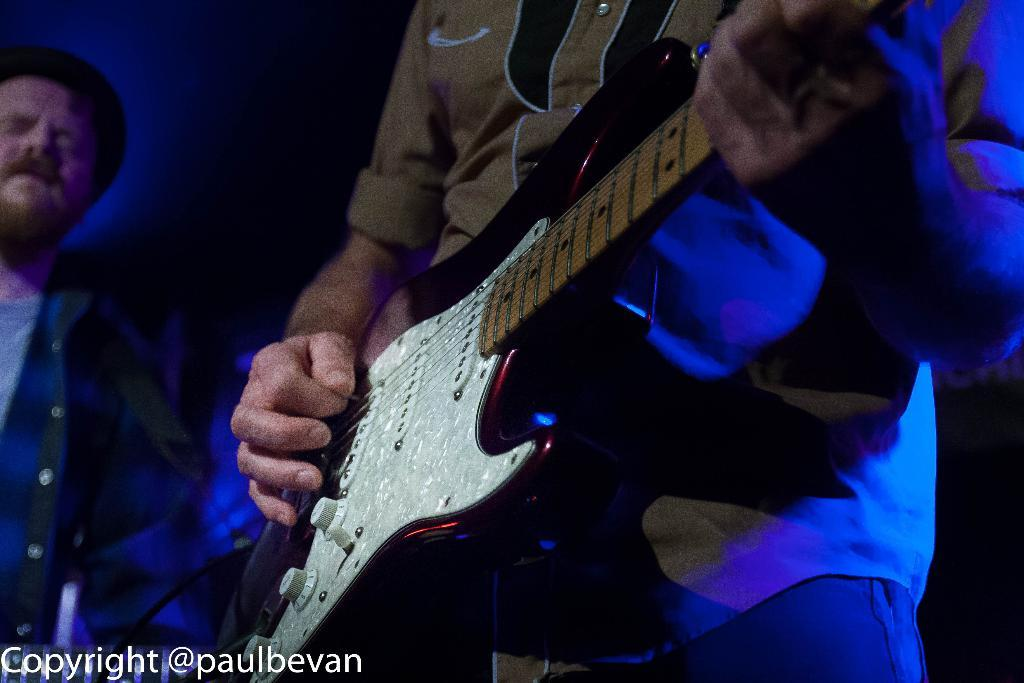What is the man in the image doing? The man is playing a guitar in the image. Can you describe the person beside the man? Unfortunately, the provided facts do not give any information about the person beside the man. What is the man holding in the image? The man is holding a guitar in the image. What type of patch is sewn onto the donkey's back in the image? There is no donkey present in the image, so there is no patch sewn onto its back. 